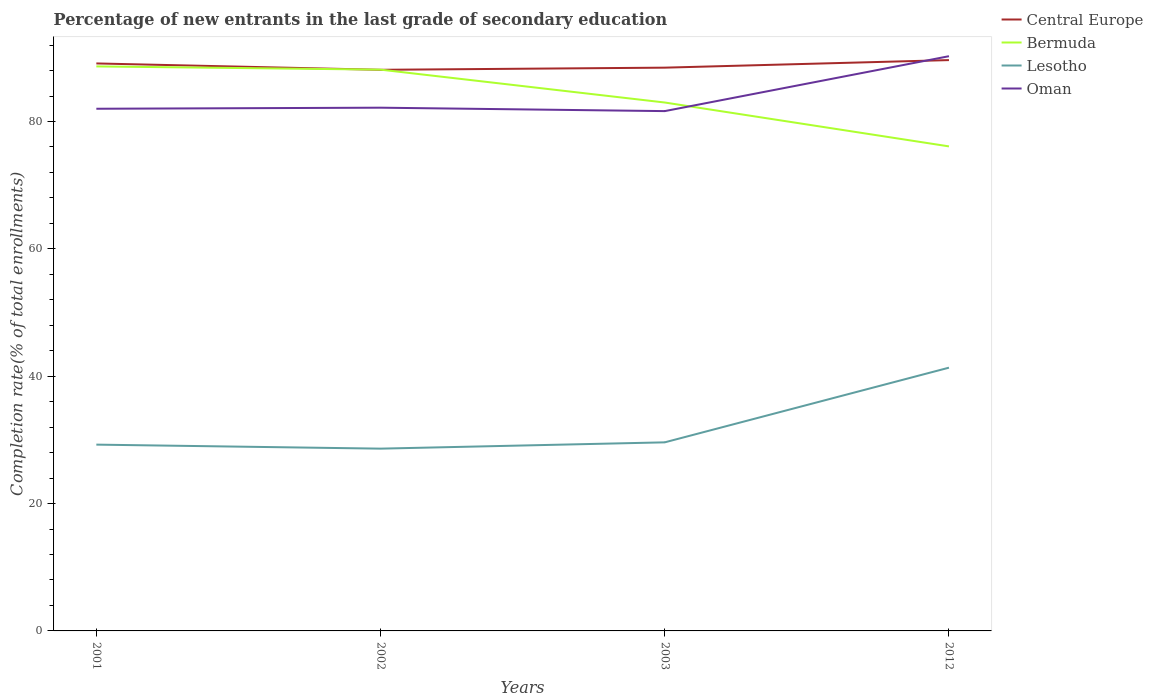Across all years, what is the maximum percentage of new entrants in Oman?
Make the answer very short. 81.63. In which year was the percentage of new entrants in Oman maximum?
Provide a succinct answer. 2003. What is the total percentage of new entrants in Lesotho in the graph?
Provide a succinct answer. 0.63. What is the difference between the highest and the second highest percentage of new entrants in Bermuda?
Keep it short and to the point. 12.56. What is the difference between the highest and the lowest percentage of new entrants in Lesotho?
Give a very brief answer. 1. How many years are there in the graph?
Ensure brevity in your answer.  4. Does the graph contain any zero values?
Offer a terse response. No. How many legend labels are there?
Give a very brief answer. 4. What is the title of the graph?
Give a very brief answer. Percentage of new entrants in the last grade of secondary education. What is the label or title of the Y-axis?
Your answer should be very brief. Completion rate(% of total enrollments). What is the Completion rate(% of total enrollments) of Central Europe in 2001?
Give a very brief answer. 89.12. What is the Completion rate(% of total enrollments) in Bermuda in 2001?
Keep it short and to the point. 88.65. What is the Completion rate(% of total enrollments) of Lesotho in 2001?
Offer a terse response. 29.26. What is the Completion rate(% of total enrollments) in Oman in 2001?
Keep it short and to the point. 82.01. What is the Completion rate(% of total enrollments) in Central Europe in 2002?
Offer a very short reply. 88.12. What is the Completion rate(% of total enrollments) in Bermuda in 2002?
Keep it short and to the point. 88.15. What is the Completion rate(% of total enrollments) in Lesotho in 2002?
Offer a very short reply. 28.63. What is the Completion rate(% of total enrollments) in Oman in 2002?
Your answer should be very brief. 82.17. What is the Completion rate(% of total enrollments) in Central Europe in 2003?
Provide a succinct answer. 88.46. What is the Completion rate(% of total enrollments) of Bermuda in 2003?
Provide a short and direct response. 82.99. What is the Completion rate(% of total enrollments) in Lesotho in 2003?
Provide a succinct answer. 29.62. What is the Completion rate(% of total enrollments) of Oman in 2003?
Keep it short and to the point. 81.63. What is the Completion rate(% of total enrollments) of Central Europe in 2012?
Make the answer very short. 89.65. What is the Completion rate(% of total enrollments) in Bermuda in 2012?
Your answer should be very brief. 76.1. What is the Completion rate(% of total enrollments) in Lesotho in 2012?
Your answer should be compact. 41.34. What is the Completion rate(% of total enrollments) in Oman in 2012?
Keep it short and to the point. 90.26. Across all years, what is the maximum Completion rate(% of total enrollments) of Central Europe?
Provide a short and direct response. 89.65. Across all years, what is the maximum Completion rate(% of total enrollments) in Bermuda?
Give a very brief answer. 88.65. Across all years, what is the maximum Completion rate(% of total enrollments) of Lesotho?
Offer a terse response. 41.34. Across all years, what is the maximum Completion rate(% of total enrollments) of Oman?
Give a very brief answer. 90.26. Across all years, what is the minimum Completion rate(% of total enrollments) of Central Europe?
Offer a terse response. 88.12. Across all years, what is the minimum Completion rate(% of total enrollments) in Bermuda?
Offer a terse response. 76.1. Across all years, what is the minimum Completion rate(% of total enrollments) of Lesotho?
Your answer should be compact. 28.63. Across all years, what is the minimum Completion rate(% of total enrollments) in Oman?
Your answer should be very brief. 81.63. What is the total Completion rate(% of total enrollments) of Central Europe in the graph?
Offer a terse response. 355.35. What is the total Completion rate(% of total enrollments) in Bermuda in the graph?
Offer a very short reply. 335.88. What is the total Completion rate(% of total enrollments) of Lesotho in the graph?
Ensure brevity in your answer.  128.84. What is the total Completion rate(% of total enrollments) of Oman in the graph?
Provide a short and direct response. 336.07. What is the difference between the Completion rate(% of total enrollments) of Bermuda in 2001 and that in 2002?
Offer a terse response. 0.51. What is the difference between the Completion rate(% of total enrollments) in Lesotho in 2001 and that in 2002?
Give a very brief answer. 0.63. What is the difference between the Completion rate(% of total enrollments) of Oman in 2001 and that in 2002?
Ensure brevity in your answer.  -0.17. What is the difference between the Completion rate(% of total enrollments) of Central Europe in 2001 and that in 2003?
Provide a succinct answer. 0.66. What is the difference between the Completion rate(% of total enrollments) in Bermuda in 2001 and that in 2003?
Your answer should be compact. 5.67. What is the difference between the Completion rate(% of total enrollments) of Lesotho in 2001 and that in 2003?
Provide a short and direct response. -0.36. What is the difference between the Completion rate(% of total enrollments) in Oman in 2001 and that in 2003?
Your answer should be very brief. 0.37. What is the difference between the Completion rate(% of total enrollments) of Central Europe in 2001 and that in 2012?
Your answer should be very brief. -0.52. What is the difference between the Completion rate(% of total enrollments) in Bermuda in 2001 and that in 2012?
Offer a terse response. 12.56. What is the difference between the Completion rate(% of total enrollments) in Lesotho in 2001 and that in 2012?
Offer a very short reply. -12.09. What is the difference between the Completion rate(% of total enrollments) of Oman in 2001 and that in 2012?
Your response must be concise. -8.25. What is the difference between the Completion rate(% of total enrollments) in Central Europe in 2002 and that in 2003?
Your answer should be compact. -0.33. What is the difference between the Completion rate(% of total enrollments) of Bermuda in 2002 and that in 2003?
Provide a short and direct response. 5.16. What is the difference between the Completion rate(% of total enrollments) of Lesotho in 2002 and that in 2003?
Ensure brevity in your answer.  -0.99. What is the difference between the Completion rate(% of total enrollments) in Oman in 2002 and that in 2003?
Offer a terse response. 0.54. What is the difference between the Completion rate(% of total enrollments) in Central Europe in 2002 and that in 2012?
Your answer should be compact. -1.52. What is the difference between the Completion rate(% of total enrollments) of Bermuda in 2002 and that in 2012?
Give a very brief answer. 12.05. What is the difference between the Completion rate(% of total enrollments) in Lesotho in 2002 and that in 2012?
Provide a short and direct response. -12.72. What is the difference between the Completion rate(% of total enrollments) of Oman in 2002 and that in 2012?
Make the answer very short. -8.09. What is the difference between the Completion rate(% of total enrollments) of Central Europe in 2003 and that in 2012?
Make the answer very short. -1.19. What is the difference between the Completion rate(% of total enrollments) in Bermuda in 2003 and that in 2012?
Give a very brief answer. 6.89. What is the difference between the Completion rate(% of total enrollments) of Lesotho in 2003 and that in 2012?
Your answer should be very brief. -11.73. What is the difference between the Completion rate(% of total enrollments) of Oman in 2003 and that in 2012?
Your answer should be compact. -8.62. What is the difference between the Completion rate(% of total enrollments) of Central Europe in 2001 and the Completion rate(% of total enrollments) of Bermuda in 2002?
Offer a terse response. 0.98. What is the difference between the Completion rate(% of total enrollments) of Central Europe in 2001 and the Completion rate(% of total enrollments) of Lesotho in 2002?
Offer a very short reply. 60.5. What is the difference between the Completion rate(% of total enrollments) in Central Europe in 2001 and the Completion rate(% of total enrollments) in Oman in 2002?
Ensure brevity in your answer.  6.95. What is the difference between the Completion rate(% of total enrollments) in Bermuda in 2001 and the Completion rate(% of total enrollments) in Lesotho in 2002?
Your answer should be very brief. 60.03. What is the difference between the Completion rate(% of total enrollments) of Bermuda in 2001 and the Completion rate(% of total enrollments) of Oman in 2002?
Your answer should be very brief. 6.48. What is the difference between the Completion rate(% of total enrollments) in Lesotho in 2001 and the Completion rate(% of total enrollments) in Oman in 2002?
Give a very brief answer. -52.91. What is the difference between the Completion rate(% of total enrollments) in Central Europe in 2001 and the Completion rate(% of total enrollments) in Bermuda in 2003?
Provide a succinct answer. 6.14. What is the difference between the Completion rate(% of total enrollments) of Central Europe in 2001 and the Completion rate(% of total enrollments) of Lesotho in 2003?
Keep it short and to the point. 59.51. What is the difference between the Completion rate(% of total enrollments) in Central Europe in 2001 and the Completion rate(% of total enrollments) in Oman in 2003?
Your answer should be very brief. 7.49. What is the difference between the Completion rate(% of total enrollments) in Bermuda in 2001 and the Completion rate(% of total enrollments) in Lesotho in 2003?
Ensure brevity in your answer.  59.04. What is the difference between the Completion rate(% of total enrollments) of Bermuda in 2001 and the Completion rate(% of total enrollments) of Oman in 2003?
Your answer should be compact. 7.02. What is the difference between the Completion rate(% of total enrollments) of Lesotho in 2001 and the Completion rate(% of total enrollments) of Oman in 2003?
Your answer should be compact. -52.38. What is the difference between the Completion rate(% of total enrollments) in Central Europe in 2001 and the Completion rate(% of total enrollments) in Bermuda in 2012?
Your answer should be compact. 13.03. What is the difference between the Completion rate(% of total enrollments) in Central Europe in 2001 and the Completion rate(% of total enrollments) in Lesotho in 2012?
Keep it short and to the point. 47.78. What is the difference between the Completion rate(% of total enrollments) of Central Europe in 2001 and the Completion rate(% of total enrollments) of Oman in 2012?
Offer a very short reply. -1.14. What is the difference between the Completion rate(% of total enrollments) of Bermuda in 2001 and the Completion rate(% of total enrollments) of Lesotho in 2012?
Your answer should be compact. 47.31. What is the difference between the Completion rate(% of total enrollments) in Bermuda in 2001 and the Completion rate(% of total enrollments) in Oman in 2012?
Provide a succinct answer. -1.6. What is the difference between the Completion rate(% of total enrollments) of Lesotho in 2001 and the Completion rate(% of total enrollments) of Oman in 2012?
Provide a short and direct response. -61. What is the difference between the Completion rate(% of total enrollments) of Central Europe in 2002 and the Completion rate(% of total enrollments) of Bermuda in 2003?
Offer a terse response. 5.14. What is the difference between the Completion rate(% of total enrollments) of Central Europe in 2002 and the Completion rate(% of total enrollments) of Lesotho in 2003?
Give a very brief answer. 58.51. What is the difference between the Completion rate(% of total enrollments) in Central Europe in 2002 and the Completion rate(% of total enrollments) in Oman in 2003?
Give a very brief answer. 6.49. What is the difference between the Completion rate(% of total enrollments) in Bermuda in 2002 and the Completion rate(% of total enrollments) in Lesotho in 2003?
Your response must be concise. 58.53. What is the difference between the Completion rate(% of total enrollments) in Bermuda in 2002 and the Completion rate(% of total enrollments) in Oman in 2003?
Provide a short and direct response. 6.51. What is the difference between the Completion rate(% of total enrollments) of Lesotho in 2002 and the Completion rate(% of total enrollments) of Oman in 2003?
Ensure brevity in your answer.  -53.01. What is the difference between the Completion rate(% of total enrollments) of Central Europe in 2002 and the Completion rate(% of total enrollments) of Bermuda in 2012?
Make the answer very short. 12.03. What is the difference between the Completion rate(% of total enrollments) in Central Europe in 2002 and the Completion rate(% of total enrollments) in Lesotho in 2012?
Ensure brevity in your answer.  46.78. What is the difference between the Completion rate(% of total enrollments) of Central Europe in 2002 and the Completion rate(% of total enrollments) of Oman in 2012?
Give a very brief answer. -2.14. What is the difference between the Completion rate(% of total enrollments) in Bermuda in 2002 and the Completion rate(% of total enrollments) in Lesotho in 2012?
Make the answer very short. 46.8. What is the difference between the Completion rate(% of total enrollments) of Bermuda in 2002 and the Completion rate(% of total enrollments) of Oman in 2012?
Your response must be concise. -2.11. What is the difference between the Completion rate(% of total enrollments) of Lesotho in 2002 and the Completion rate(% of total enrollments) of Oman in 2012?
Keep it short and to the point. -61.63. What is the difference between the Completion rate(% of total enrollments) of Central Europe in 2003 and the Completion rate(% of total enrollments) of Bermuda in 2012?
Keep it short and to the point. 12.36. What is the difference between the Completion rate(% of total enrollments) in Central Europe in 2003 and the Completion rate(% of total enrollments) in Lesotho in 2012?
Ensure brevity in your answer.  47.11. What is the difference between the Completion rate(% of total enrollments) of Central Europe in 2003 and the Completion rate(% of total enrollments) of Oman in 2012?
Your response must be concise. -1.8. What is the difference between the Completion rate(% of total enrollments) in Bermuda in 2003 and the Completion rate(% of total enrollments) in Lesotho in 2012?
Make the answer very short. 41.64. What is the difference between the Completion rate(% of total enrollments) of Bermuda in 2003 and the Completion rate(% of total enrollments) of Oman in 2012?
Provide a short and direct response. -7.27. What is the difference between the Completion rate(% of total enrollments) in Lesotho in 2003 and the Completion rate(% of total enrollments) in Oman in 2012?
Provide a short and direct response. -60.64. What is the average Completion rate(% of total enrollments) of Central Europe per year?
Your response must be concise. 88.84. What is the average Completion rate(% of total enrollments) of Bermuda per year?
Your answer should be compact. 83.97. What is the average Completion rate(% of total enrollments) of Lesotho per year?
Provide a short and direct response. 32.21. What is the average Completion rate(% of total enrollments) of Oman per year?
Keep it short and to the point. 84.02. In the year 2001, what is the difference between the Completion rate(% of total enrollments) in Central Europe and Completion rate(% of total enrollments) in Bermuda?
Keep it short and to the point. 0.47. In the year 2001, what is the difference between the Completion rate(% of total enrollments) of Central Europe and Completion rate(% of total enrollments) of Lesotho?
Make the answer very short. 59.86. In the year 2001, what is the difference between the Completion rate(% of total enrollments) of Central Europe and Completion rate(% of total enrollments) of Oman?
Keep it short and to the point. 7.12. In the year 2001, what is the difference between the Completion rate(% of total enrollments) of Bermuda and Completion rate(% of total enrollments) of Lesotho?
Keep it short and to the point. 59.4. In the year 2001, what is the difference between the Completion rate(% of total enrollments) in Bermuda and Completion rate(% of total enrollments) in Oman?
Ensure brevity in your answer.  6.65. In the year 2001, what is the difference between the Completion rate(% of total enrollments) of Lesotho and Completion rate(% of total enrollments) of Oman?
Offer a terse response. -52.75. In the year 2002, what is the difference between the Completion rate(% of total enrollments) in Central Europe and Completion rate(% of total enrollments) in Bermuda?
Offer a terse response. -0.02. In the year 2002, what is the difference between the Completion rate(% of total enrollments) of Central Europe and Completion rate(% of total enrollments) of Lesotho?
Offer a very short reply. 59.5. In the year 2002, what is the difference between the Completion rate(% of total enrollments) of Central Europe and Completion rate(% of total enrollments) of Oman?
Offer a terse response. 5.95. In the year 2002, what is the difference between the Completion rate(% of total enrollments) of Bermuda and Completion rate(% of total enrollments) of Lesotho?
Give a very brief answer. 59.52. In the year 2002, what is the difference between the Completion rate(% of total enrollments) of Bermuda and Completion rate(% of total enrollments) of Oman?
Make the answer very short. 5.98. In the year 2002, what is the difference between the Completion rate(% of total enrollments) in Lesotho and Completion rate(% of total enrollments) in Oman?
Your answer should be very brief. -53.55. In the year 2003, what is the difference between the Completion rate(% of total enrollments) in Central Europe and Completion rate(% of total enrollments) in Bermuda?
Give a very brief answer. 5.47. In the year 2003, what is the difference between the Completion rate(% of total enrollments) of Central Europe and Completion rate(% of total enrollments) of Lesotho?
Provide a short and direct response. 58.84. In the year 2003, what is the difference between the Completion rate(% of total enrollments) of Central Europe and Completion rate(% of total enrollments) of Oman?
Offer a terse response. 6.82. In the year 2003, what is the difference between the Completion rate(% of total enrollments) in Bermuda and Completion rate(% of total enrollments) in Lesotho?
Keep it short and to the point. 53.37. In the year 2003, what is the difference between the Completion rate(% of total enrollments) in Bermuda and Completion rate(% of total enrollments) in Oman?
Make the answer very short. 1.35. In the year 2003, what is the difference between the Completion rate(% of total enrollments) in Lesotho and Completion rate(% of total enrollments) in Oman?
Provide a short and direct response. -52.02. In the year 2012, what is the difference between the Completion rate(% of total enrollments) of Central Europe and Completion rate(% of total enrollments) of Bermuda?
Keep it short and to the point. 13.55. In the year 2012, what is the difference between the Completion rate(% of total enrollments) in Central Europe and Completion rate(% of total enrollments) in Lesotho?
Your answer should be very brief. 48.3. In the year 2012, what is the difference between the Completion rate(% of total enrollments) in Central Europe and Completion rate(% of total enrollments) in Oman?
Provide a succinct answer. -0.61. In the year 2012, what is the difference between the Completion rate(% of total enrollments) in Bermuda and Completion rate(% of total enrollments) in Lesotho?
Your response must be concise. 34.75. In the year 2012, what is the difference between the Completion rate(% of total enrollments) of Bermuda and Completion rate(% of total enrollments) of Oman?
Your answer should be very brief. -14.16. In the year 2012, what is the difference between the Completion rate(% of total enrollments) of Lesotho and Completion rate(% of total enrollments) of Oman?
Offer a very short reply. -48.92. What is the ratio of the Completion rate(% of total enrollments) of Central Europe in 2001 to that in 2002?
Provide a short and direct response. 1.01. What is the ratio of the Completion rate(% of total enrollments) of Bermuda in 2001 to that in 2002?
Offer a very short reply. 1.01. What is the ratio of the Completion rate(% of total enrollments) of Oman in 2001 to that in 2002?
Ensure brevity in your answer.  1. What is the ratio of the Completion rate(% of total enrollments) in Central Europe in 2001 to that in 2003?
Your answer should be compact. 1.01. What is the ratio of the Completion rate(% of total enrollments) of Bermuda in 2001 to that in 2003?
Ensure brevity in your answer.  1.07. What is the ratio of the Completion rate(% of total enrollments) of Lesotho in 2001 to that in 2003?
Give a very brief answer. 0.99. What is the ratio of the Completion rate(% of total enrollments) in Central Europe in 2001 to that in 2012?
Offer a terse response. 0.99. What is the ratio of the Completion rate(% of total enrollments) in Bermuda in 2001 to that in 2012?
Provide a succinct answer. 1.17. What is the ratio of the Completion rate(% of total enrollments) of Lesotho in 2001 to that in 2012?
Offer a terse response. 0.71. What is the ratio of the Completion rate(% of total enrollments) of Oman in 2001 to that in 2012?
Give a very brief answer. 0.91. What is the ratio of the Completion rate(% of total enrollments) in Bermuda in 2002 to that in 2003?
Your response must be concise. 1.06. What is the ratio of the Completion rate(% of total enrollments) in Lesotho in 2002 to that in 2003?
Your answer should be compact. 0.97. What is the ratio of the Completion rate(% of total enrollments) in Oman in 2002 to that in 2003?
Give a very brief answer. 1.01. What is the ratio of the Completion rate(% of total enrollments) in Central Europe in 2002 to that in 2012?
Keep it short and to the point. 0.98. What is the ratio of the Completion rate(% of total enrollments) in Bermuda in 2002 to that in 2012?
Offer a terse response. 1.16. What is the ratio of the Completion rate(% of total enrollments) of Lesotho in 2002 to that in 2012?
Make the answer very short. 0.69. What is the ratio of the Completion rate(% of total enrollments) of Oman in 2002 to that in 2012?
Your answer should be very brief. 0.91. What is the ratio of the Completion rate(% of total enrollments) of Central Europe in 2003 to that in 2012?
Your answer should be compact. 0.99. What is the ratio of the Completion rate(% of total enrollments) in Bermuda in 2003 to that in 2012?
Your answer should be very brief. 1.09. What is the ratio of the Completion rate(% of total enrollments) of Lesotho in 2003 to that in 2012?
Your response must be concise. 0.72. What is the ratio of the Completion rate(% of total enrollments) of Oman in 2003 to that in 2012?
Your answer should be compact. 0.9. What is the difference between the highest and the second highest Completion rate(% of total enrollments) in Central Europe?
Provide a succinct answer. 0.52. What is the difference between the highest and the second highest Completion rate(% of total enrollments) in Bermuda?
Give a very brief answer. 0.51. What is the difference between the highest and the second highest Completion rate(% of total enrollments) in Lesotho?
Ensure brevity in your answer.  11.73. What is the difference between the highest and the second highest Completion rate(% of total enrollments) of Oman?
Keep it short and to the point. 8.09. What is the difference between the highest and the lowest Completion rate(% of total enrollments) of Central Europe?
Provide a short and direct response. 1.52. What is the difference between the highest and the lowest Completion rate(% of total enrollments) of Bermuda?
Your answer should be compact. 12.56. What is the difference between the highest and the lowest Completion rate(% of total enrollments) of Lesotho?
Offer a terse response. 12.72. What is the difference between the highest and the lowest Completion rate(% of total enrollments) of Oman?
Provide a succinct answer. 8.62. 